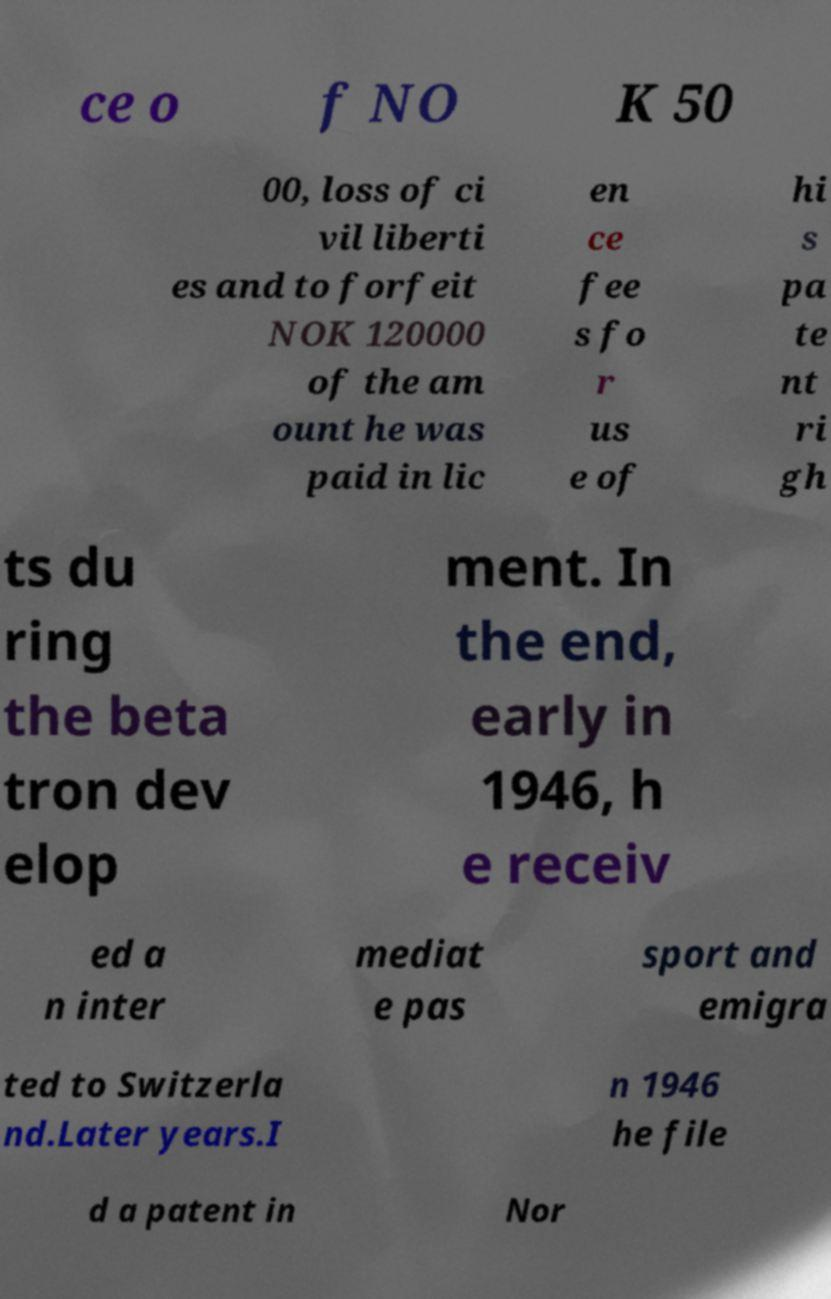Please identify and transcribe the text found in this image. ce o f NO K 50 00, loss of ci vil liberti es and to forfeit NOK 120000 of the am ount he was paid in lic en ce fee s fo r us e of hi s pa te nt ri gh ts du ring the beta tron dev elop ment. In the end, early in 1946, h e receiv ed a n inter mediat e pas sport and emigra ted to Switzerla nd.Later years.I n 1946 he file d a patent in Nor 